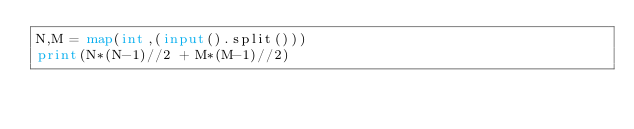Convert code to text. <code><loc_0><loc_0><loc_500><loc_500><_Python_>N,M = map(int,(input().split()))
print(N*(N-1)//2 + M*(M-1)//2)</code> 